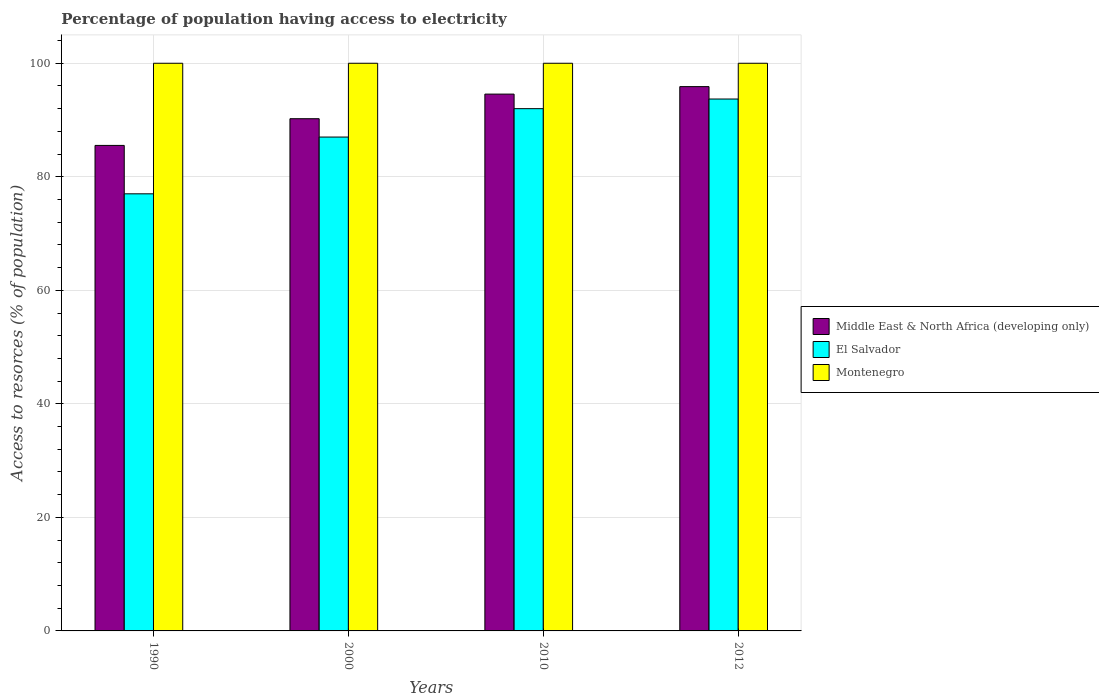How many different coloured bars are there?
Offer a terse response. 3. How many groups of bars are there?
Make the answer very short. 4. What is the label of the 3rd group of bars from the left?
Give a very brief answer. 2010. What is the percentage of population having access to electricity in El Salvador in 2000?
Make the answer very short. 87. Across all years, what is the maximum percentage of population having access to electricity in Middle East & North Africa (developing only)?
Your response must be concise. 95.88. Across all years, what is the minimum percentage of population having access to electricity in Middle East & North Africa (developing only)?
Your answer should be compact. 85.53. What is the total percentage of population having access to electricity in Middle East & North Africa (developing only) in the graph?
Offer a terse response. 366.21. What is the difference between the percentage of population having access to electricity in Montenegro in 2000 and the percentage of population having access to electricity in Middle East & North Africa (developing only) in 2012?
Provide a short and direct response. 4.12. In the year 2012, what is the difference between the percentage of population having access to electricity in Montenegro and percentage of population having access to electricity in Middle East & North Africa (developing only)?
Offer a terse response. 4.12. What is the ratio of the percentage of population having access to electricity in El Salvador in 2000 to that in 2010?
Your response must be concise. 0.95. Is the percentage of population having access to electricity in Middle East & North Africa (developing only) in 2000 less than that in 2012?
Offer a very short reply. Yes. Is the difference between the percentage of population having access to electricity in Montenegro in 1990 and 2010 greater than the difference between the percentage of population having access to electricity in Middle East & North Africa (developing only) in 1990 and 2010?
Provide a short and direct response. Yes. What is the difference between the highest and the second highest percentage of population having access to electricity in Montenegro?
Keep it short and to the point. 0. What is the difference between the highest and the lowest percentage of population having access to electricity in Montenegro?
Provide a short and direct response. 0. In how many years, is the percentage of population having access to electricity in Montenegro greater than the average percentage of population having access to electricity in Montenegro taken over all years?
Provide a succinct answer. 0. What does the 3rd bar from the left in 1990 represents?
Provide a succinct answer. Montenegro. What does the 1st bar from the right in 1990 represents?
Your response must be concise. Montenegro. Is it the case that in every year, the sum of the percentage of population having access to electricity in Montenegro and percentage of population having access to electricity in Middle East & North Africa (developing only) is greater than the percentage of population having access to electricity in El Salvador?
Your answer should be very brief. Yes. How many bars are there?
Your response must be concise. 12. Are all the bars in the graph horizontal?
Provide a succinct answer. No. How many years are there in the graph?
Give a very brief answer. 4. What is the difference between two consecutive major ticks on the Y-axis?
Offer a very short reply. 20. Are the values on the major ticks of Y-axis written in scientific E-notation?
Your answer should be compact. No. Does the graph contain any zero values?
Offer a terse response. No. Does the graph contain grids?
Ensure brevity in your answer.  Yes. How are the legend labels stacked?
Provide a short and direct response. Vertical. What is the title of the graph?
Your answer should be very brief. Percentage of population having access to electricity. What is the label or title of the Y-axis?
Your response must be concise. Access to resorces (% of population). What is the Access to resorces (% of population) in Middle East & North Africa (developing only) in 1990?
Offer a very short reply. 85.53. What is the Access to resorces (% of population) of Middle East & North Africa (developing only) in 2000?
Your answer should be very brief. 90.23. What is the Access to resorces (% of population) in Montenegro in 2000?
Give a very brief answer. 100. What is the Access to resorces (% of population) of Middle East & North Africa (developing only) in 2010?
Offer a terse response. 94.57. What is the Access to resorces (% of population) in El Salvador in 2010?
Make the answer very short. 92. What is the Access to resorces (% of population) of Middle East & North Africa (developing only) in 2012?
Your response must be concise. 95.88. What is the Access to resorces (% of population) of El Salvador in 2012?
Offer a very short reply. 93.7. What is the Access to resorces (% of population) in Montenegro in 2012?
Your answer should be compact. 100. Across all years, what is the maximum Access to resorces (% of population) in Middle East & North Africa (developing only)?
Your answer should be compact. 95.88. Across all years, what is the maximum Access to resorces (% of population) in El Salvador?
Ensure brevity in your answer.  93.7. Across all years, what is the minimum Access to resorces (% of population) in Middle East & North Africa (developing only)?
Provide a succinct answer. 85.53. Across all years, what is the minimum Access to resorces (% of population) of El Salvador?
Ensure brevity in your answer.  77. What is the total Access to resorces (% of population) of Middle East & North Africa (developing only) in the graph?
Your answer should be compact. 366.21. What is the total Access to resorces (% of population) in El Salvador in the graph?
Make the answer very short. 349.7. What is the total Access to resorces (% of population) in Montenegro in the graph?
Give a very brief answer. 400. What is the difference between the Access to resorces (% of population) of Middle East & North Africa (developing only) in 1990 and that in 2000?
Provide a succinct answer. -4.7. What is the difference between the Access to resorces (% of population) of Middle East & North Africa (developing only) in 1990 and that in 2010?
Your answer should be very brief. -9.04. What is the difference between the Access to resorces (% of population) in El Salvador in 1990 and that in 2010?
Provide a succinct answer. -15. What is the difference between the Access to resorces (% of population) of Montenegro in 1990 and that in 2010?
Provide a succinct answer. 0. What is the difference between the Access to resorces (% of population) in Middle East & North Africa (developing only) in 1990 and that in 2012?
Offer a very short reply. -10.36. What is the difference between the Access to resorces (% of population) of El Salvador in 1990 and that in 2012?
Your response must be concise. -16.7. What is the difference between the Access to resorces (% of population) of Montenegro in 1990 and that in 2012?
Make the answer very short. 0. What is the difference between the Access to resorces (% of population) in Middle East & North Africa (developing only) in 2000 and that in 2010?
Provide a short and direct response. -4.34. What is the difference between the Access to resorces (% of population) of El Salvador in 2000 and that in 2010?
Offer a terse response. -5. What is the difference between the Access to resorces (% of population) in Middle East & North Africa (developing only) in 2000 and that in 2012?
Give a very brief answer. -5.65. What is the difference between the Access to resorces (% of population) of El Salvador in 2000 and that in 2012?
Your answer should be compact. -6.7. What is the difference between the Access to resorces (% of population) in Montenegro in 2000 and that in 2012?
Provide a short and direct response. 0. What is the difference between the Access to resorces (% of population) of Middle East & North Africa (developing only) in 2010 and that in 2012?
Provide a succinct answer. -1.32. What is the difference between the Access to resorces (% of population) in Montenegro in 2010 and that in 2012?
Provide a succinct answer. 0. What is the difference between the Access to resorces (% of population) in Middle East & North Africa (developing only) in 1990 and the Access to resorces (% of population) in El Salvador in 2000?
Your answer should be very brief. -1.47. What is the difference between the Access to resorces (% of population) in Middle East & North Africa (developing only) in 1990 and the Access to resorces (% of population) in Montenegro in 2000?
Offer a very short reply. -14.47. What is the difference between the Access to resorces (% of population) in El Salvador in 1990 and the Access to resorces (% of population) in Montenegro in 2000?
Keep it short and to the point. -23. What is the difference between the Access to resorces (% of population) in Middle East & North Africa (developing only) in 1990 and the Access to resorces (% of population) in El Salvador in 2010?
Offer a terse response. -6.47. What is the difference between the Access to resorces (% of population) in Middle East & North Africa (developing only) in 1990 and the Access to resorces (% of population) in Montenegro in 2010?
Give a very brief answer. -14.47. What is the difference between the Access to resorces (% of population) of El Salvador in 1990 and the Access to resorces (% of population) of Montenegro in 2010?
Give a very brief answer. -23. What is the difference between the Access to resorces (% of population) in Middle East & North Africa (developing only) in 1990 and the Access to resorces (% of population) in El Salvador in 2012?
Your answer should be very brief. -8.17. What is the difference between the Access to resorces (% of population) in Middle East & North Africa (developing only) in 1990 and the Access to resorces (% of population) in Montenegro in 2012?
Provide a short and direct response. -14.47. What is the difference between the Access to resorces (% of population) in Middle East & North Africa (developing only) in 2000 and the Access to resorces (% of population) in El Salvador in 2010?
Ensure brevity in your answer.  -1.77. What is the difference between the Access to resorces (% of population) of Middle East & North Africa (developing only) in 2000 and the Access to resorces (% of population) of Montenegro in 2010?
Provide a short and direct response. -9.77. What is the difference between the Access to resorces (% of population) of Middle East & North Africa (developing only) in 2000 and the Access to resorces (% of population) of El Salvador in 2012?
Offer a very short reply. -3.47. What is the difference between the Access to resorces (% of population) of Middle East & North Africa (developing only) in 2000 and the Access to resorces (% of population) of Montenegro in 2012?
Offer a terse response. -9.77. What is the difference between the Access to resorces (% of population) in Middle East & North Africa (developing only) in 2010 and the Access to resorces (% of population) in El Salvador in 2012?
Your answer should be very brief. 0.87. What is the difference between the Access to resorces (% of population) of Middle East & North Africa (developing only) in 2010 and the Access to resorces (% of population) of Montenegro in 2012?
Make the answer very short. -5.43. What is the average Access to resorces (% of population) in Middle East & North Africa (developing only) per year?
Your answer should be compact. 91.55. What is the average Access to resorces (% of population) of El Salvador per year?
Give a very brief answer. 87.42. What is the average Access to resorces (% of population) of Montenegro per year?
Offer a terse response. 100. In the year 1990, what is the difference between the Access to resorces (% of population) of Middle East & North Africa (developing only) and Access to resorces (% of population) of El Salvador?
Your answer should be compact. 8.53. In the year 1990, what is the difference between the Access to resorces (% of population) of Middle East & North Africa (developing only) and Access to resorces (% of population) of Montenegro?
Give a very brief answer. -14.47. In the year 2000, what is the difference between the Access to resorces (% of population) in Middle East & North Africa (developing only) and Access to resorces (% of population) in El Salvador?
Offer a very short reply. 3.23. In the year 2000, what is the difference between the Access to resorces (% of population) of Middle East & North Africa (developing only) and Access to resorces (% of population) of Montenegro?
Keep it short and to the point. -9.77. In the year 2000, what is the difference between the Access to resorces (% of population) in El Salvador and Access to resorces (% of population) in Montenegro?
Your response must be concise. -13. In the year 2010, what is the difference between the Access to resorces (% of population) of Middle East & North Africa (developing only) and Access to resorces (% of population) of El Salvador?
Ensure brevity in your answer.  2.57. In the year 2010, what is the difference between the Access to resorces (% of population) of Middle East & North Africa (developing only) and Access to resorces (% of population) of Montenegro?
Offer a terse response. -5.43. In the year 2010, what is the difference between the Access to resorces (% of population) in El Salvador and Access to resorces (% of population) in Montenegro?
Your answer should be very brief. -8. In the year 2012, what is the difference between the Access to resorces (% of population) in Middle East & North Africa (developing only) and Access to resorces (% of population) in El Salvador?
Give a very brief answer. 2.18. In the year 2012, what is the difference between the Access to resorces (% of population) of Middle East & North Africa (developing only) and Access to resorces (% of population) of Montenegro?
Offer a very short reply. -4.12. What is the ratio of the Access to resorces (% of population) in Middle East & North Africa (developing only) in 1990 to that in 2000?
Give a very brief answer. 0.95. What is the ratio of the Access to resorces (% of population) of El Salvador in 1990 to that in 2000?
Provide a succinct answer. 0.89. What is the ratio of the Access to resorces (% of population) in Montenegro in 1990 to that in 2000?
Provide a short and direct response. 1. What is the ratio of the Access to resorces (% of population) of Middle East & North Africa (developing only) in 1990 to that in 2010?
Ensure brevity in your answer.  0.9. What is the ratio of the Access to resorces (% of population) in El Salvador in 1990 to that in 2010?
Make the answer very short. 0.84. What is the ratio of the Access to resorces (% of population) in Montenegro in 1990 to that in 2010?
Ensure brevity in your answer.  1. What is the ratio of the Access to resorces (% of population) in Middle East & North Africa (developing only) in 1990 to that in 2012?
Offer a terse response. 0.89. What is the ratio of the Access to resorces (% of population) in El Salvador in 1990 to that in 2012?
Give a very brief answer. 0.82. What is the ratio of the Access to resorces (% of population) in Middle East & North Africa (developing only) in 2000 to that in 2010?
Your answer should be very brief. 0.95. What is the ratio of the Access to resorces (% of population) in El Salvador in 2000 to that in 2010?
Your answer should be compact. 0.95. What is the ratio of the Access to resorces (% of population) of Montenegro in 2000 to that in 2010?
Provide a short and direct response. 1. What is the ratio of the Access to resorces (% of population) of Middle East & North Africa (developing only) in 2000 to that in 2012?
Your response must be concise. 0.94. What is the ratio of the Access to resorces (% of population) in El Salvador in 2000 to that in 2012?
Give a very brief answer. 0.93. What is the ratio of the Access to resorces (% of population) in Montenegro in 2000 to that in 2012?
Provide a short and direct response. 1. What is the ratio of the Access to resorces (% of population) in Middle East & North Africa (developing only) in 2010 to that in 2012?
Ensure brevity in your answer.  0.99. What is the ratio of the Access to resorces (% of population) in El Salvador in 2010 to that in 2012?
Provide a short and direct response. 0.98. What is the difference between the highest and the second highest Access to resorces (% of population) in Middle East & North Africa (developing only)?
Keep it short and to the point. 1.32. What is the difference between the highest and the lowest Access to resorces (% of population) of Middle East & North Africa (developing only)?
Make the answer very short. 10.36. What is the difference between the highest and the lowest Access to resorces (% of population) in El Salvador?
Provide a succinct answer. 16.7. 